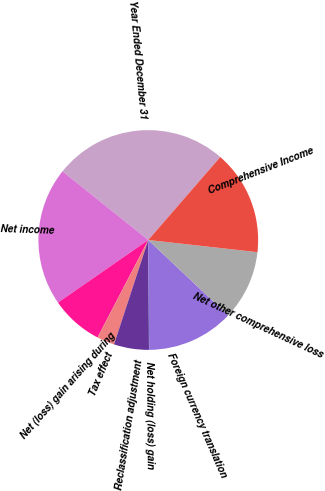<chart> <loc_0><loc_0><loc_500><loc_500><pie_chart><fcel>Year Ended December 31<fcel>Net income<fcel>Net (loss) gain arising during<fcel>Tax effect<fcel>Reclassification adjustment<fcel>Net holding (loss) gain<fcel>Foreign currency translation<fcel>Net other comprehensive loss<fcel>Comprehensive Income<nl><fcel>25.63%<fcel>20.4%<fcel>7.71%<fcel>2.59%<fcel>5.15%<fcel>0.03%<fcel>12.83%<fcel>10.27%<fcel>15.39%<nl></chart> 